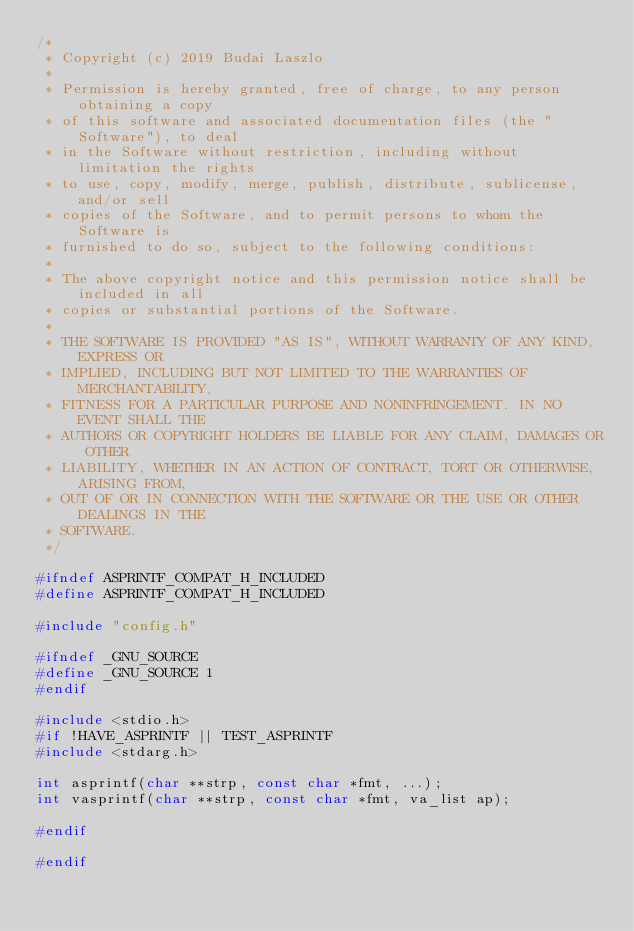Convert code to text. <code><loc_0><loc_0><loc_500><loc_500><_C_>/*
 * Copyright (c) 2019 Budai Laszlo
 *
 * Permission is hereby granted, free of charge, to any person obtaining a copy
 * of this software and associated documentation files (the "Software"), to deal
 * in the Software without restriction, including without limitation the rights
 * to use, copy, modify, merge, publish, distribute, sublicense, and/or sell
 * copies of the Software, and to permit persons to whom the Software is
 * furnished to do so, subject to the following conditions:
 * 
 * The above copyright notice and this permission notice shall be included in all
 * copies or substantial portions of the Software.
 *
 * THE SOFTWARE IS PROVIDED "AS IS", WITHOUT WARRANTY OF ANY KIND, EXPRESS OR
 * IMPLIED, INCLUDING BUT NOT LIMITED TO THE WARRANTIES OF MERCHANTABILITY,
 * FITNESS FOR A PARTICULAR PURPOSE AND NONINFRINGEMENT. IN NO EVENT SHALL THE
 * AUTHORS OR COPYRIGHT HOLDERS BE LIABLE FOR ANY CLAIM, DAMAGES OR OTHER
 * LIABILITY, WHETHER IN AN ACTION OF CONTRACT, TORT OR OTHERWISE, ARISING FROM,
 * OUT OF OR IN CONNECTION WITH THE SOFTWARE OR THE USE OR OTHER DEALINGS IN THE
 * SOFTWARE.
 */

#ifndef ASPRINTF_COMPAT_H_INCLUDED
#define ASPRINTF_COMPAT_H_INCLUDED

#include "config.h"

#ifndef _GNU_SOURCE
#define _GNU_SOURCE 1
#endif

#include <stdio.h>
#if !HAVE_ASPRINTF || TEST_ASPRINTF
#include <stdarg.h>

int asprintf(char **strp, const char *fmt, ...);
int vasprintf(char **strp, const char *fmt, va_list ap);

#endif

#endif

</code> 